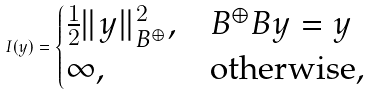<formula> <loc_0><loc_0><loc_500><loc_500>I ( y ) = \begin{cases} \frac { 1 } { 2 } \| y \| ^ { 2 } _ { B ^ { \oplus } } , & B ^ { \oplus } B y = y \\ \infty , & \text {otherwise} , \end{cases}</formula> 